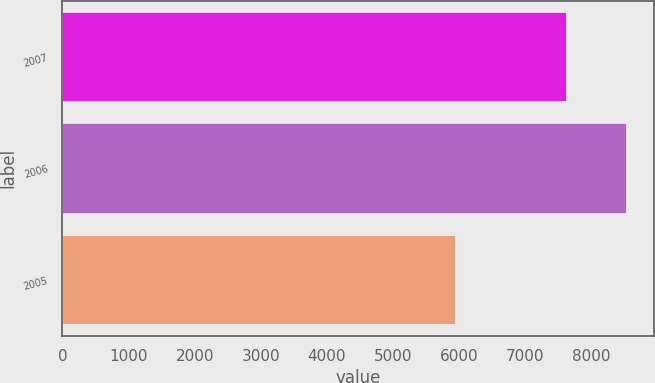Convert chart. <chart><loc_0><loc_0><loc_500><loc_500><bar_chart><fcel>2007<fcel>2006<fcel>2005<nl><fcel>7621<fcel>8514<fcel>5932<nl></chart> 